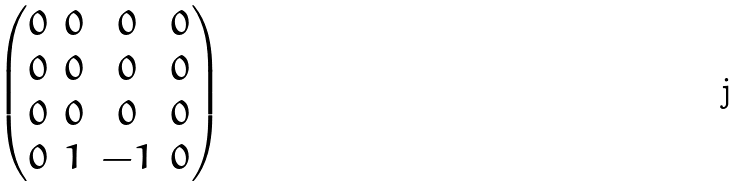<formula> <loc_0><loc_0><loc_500><loc_500>\begin{pmatrix} 0 & 0 & 0 & 0 \\ 0 & 0 & 0 & 0 \\ 0 & 0 & 0 & 0 \\ 0 & 1 & - 1 & 0 \\ \end{pmatrix}</formula> 